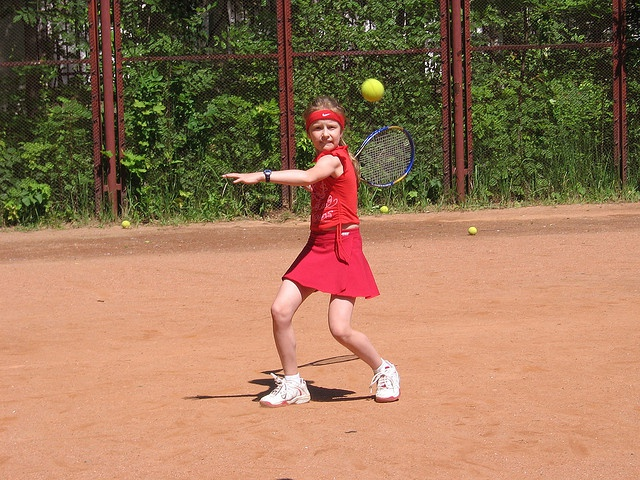Describe the objects in this image and their specific colors. I can see people in black, salmon, lightpink, white, and brown tones, tennis racket in black, gray, and darkgreen tones, sports ball in black, khaki, and olive tones, sports ball in black, khaki, and olive tones, and sports ball in black, khaki, tan, and olive tones in this image. 